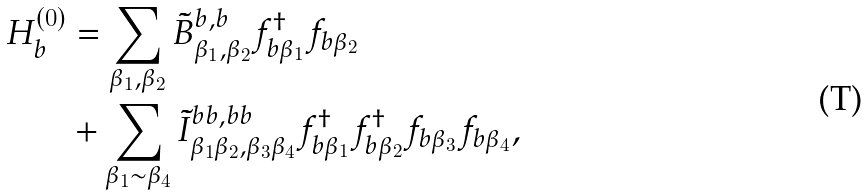Convert formula to latex. <formula><loc_0><loc_0><loc_500><loc_500>H ^ { ( 0 ) } _ { b } & = \sum _ { \beta _ { 1 } , \beta _ { 2 } } { \tilde { B } } ^ { b , b } _ { \beta _ { 1 } , \beta _ { 2 } } f ^ { \dag } _ { b \beta _ { 1 } } f _ { b \beta _ { 2 } } \\ & + \sum _ { \beta _ { 1 } \sim \beta _ { 4 } } { \tilde { I } } ^ { b b , b b } _ { \beta _ { 1 } \beta _ { 2 } , \beta _ { 3 } \beta _ { 4 } } f ^ { \dag } _ { b \beta _ { 1 } } f ^ { \dag } _ { b \beta _ { 2 } } f _ { b \beta _ { 3 } } f _ { b \beta _ { 4 } } ,</formula> 